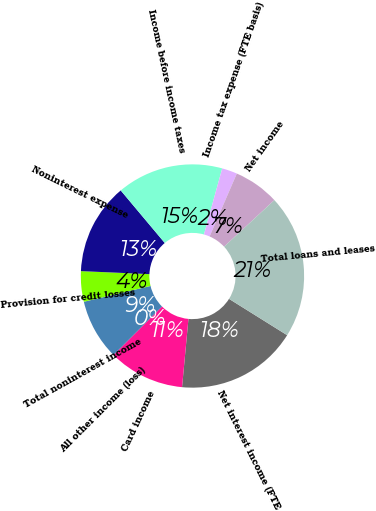<chart> <loc_0><loc_0><loc_500><loc_500><pie_chart><fcel>Net interest income (FTE<fcel>Card income<fcel>All other income (loss)<fcel>Total noninterest income<fcel>Provision for credit losses<fcel>Noninterest expense<fcel>Income before income taxes<fcel>Income tax expense (FTE basis)<fcel>Net income<fcel>Total loans and leases<nl><fcel>17.6%<fcel>11.0%<fcel>0.01%<fcel>8.8%<fcel>4.4%<fcel>13.2%<fcel>15.4%<fcel>2.21%<fcel>6.6%<fcel>20.79%<nl></chart> 